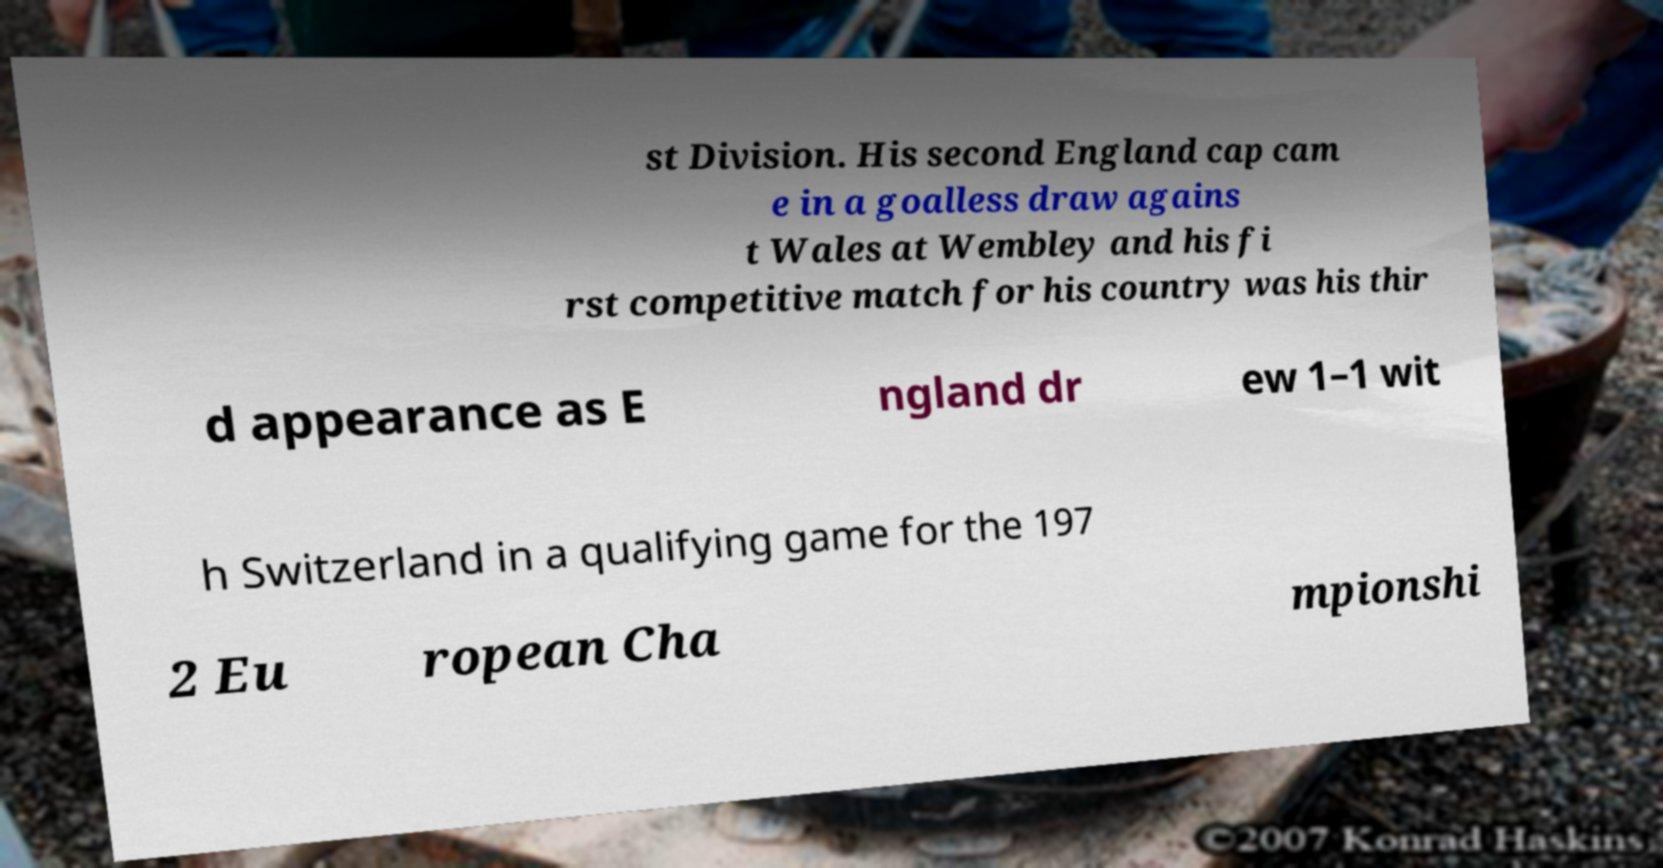Can you read and provide the text displayed in the image?This photo seems to have some interesting text. Can you extract and type it out for me? st Division. His second England cap cam e in a goalless draw agains t Wales at Wembley and his fi rst competitive match for his country was his thir d appearance as E ngland dr ew 1–1 wit h Switzerland in a qualifying game for the 197 2 Eu ropean Cha mpionshi 